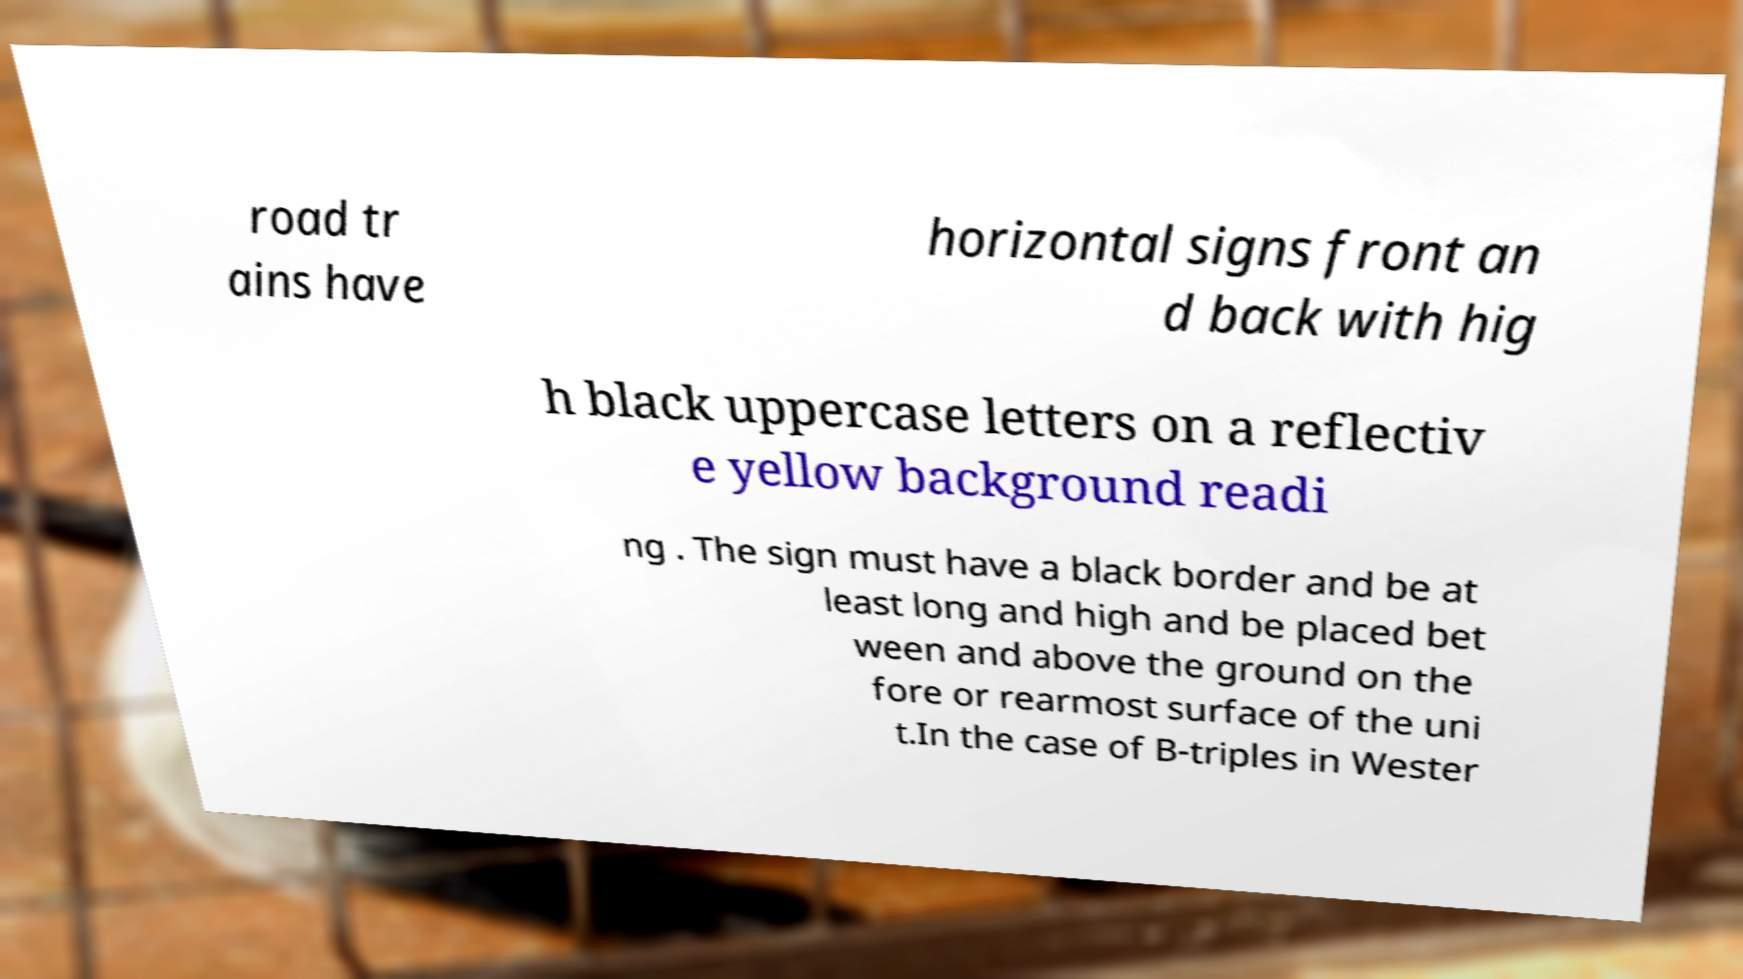What messages or text are displayed in this image? I need them in a readable, typed format. road tr ains have horizontal signs front an d back with hig h black uppercase letters on a reflectiv e yellow background readi ng . The sign must have a black border and be at least long and high and be placed bet ween and above the ground on the fore or rearmost surface of the uni t.In the case of B-triples in Wester 